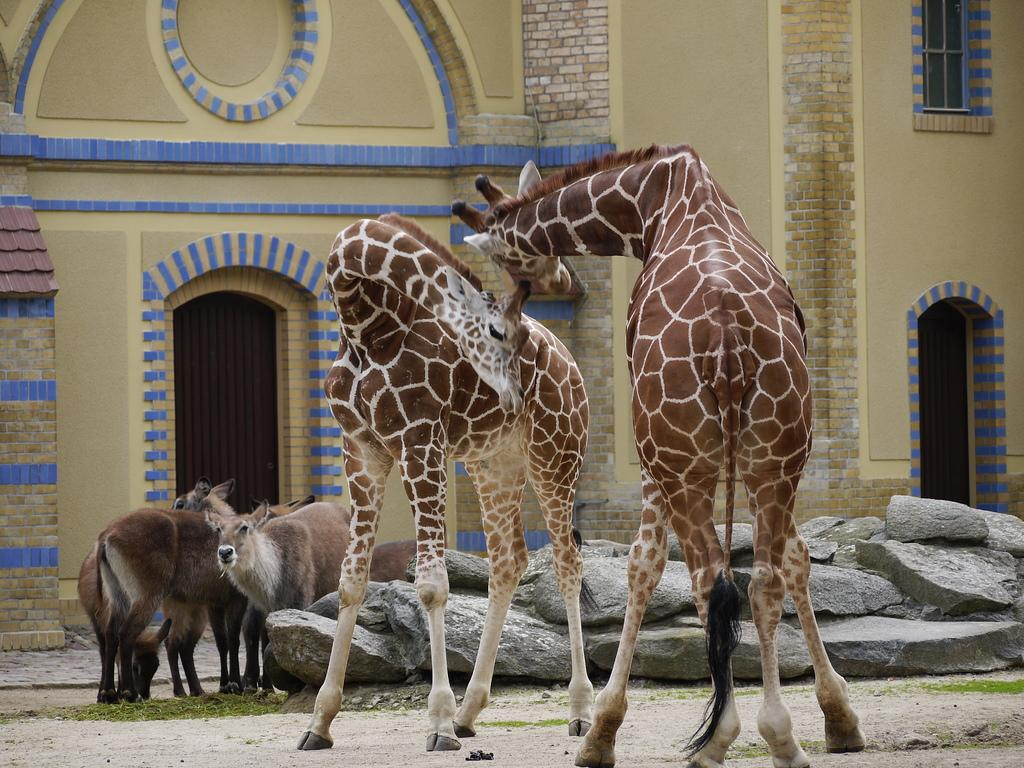What type of animals can be seen in the image? There are giraffes in the image. Are there any other animals besides giraffes in the image? Yes, there are other animals in the image. What can be seen in the background of the image? There is a building with arches and windows in the background of the image. What type of vegetation is visible in the image? There is grass visible in the image. What type of music can be heard playing in the image? There is no music present in the image; it is a still image of animals and a building. 